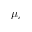<formula> <loc_0><loc_0><loc_500><loc_500>\mu _ { c }</formula> 